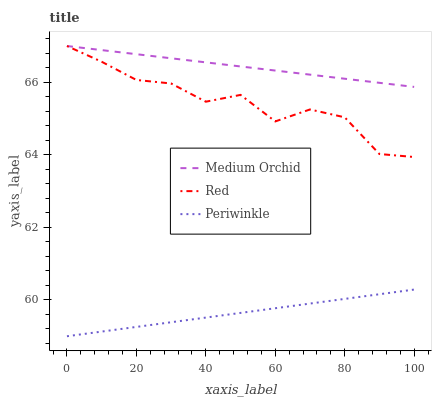Does Periwinkle have the minimum area under the curve?
Answer yes or no. Yes. Does Medium Orchid have the maximum area under the curve?
Answer yes or no. Yes. Does Red have the minimum area under the curve?
Answer yes or no. No. Does Red have the maximum area under the curve?
Answer yes or no. No. Is Medium Orchid the smoothest?
Answer yes or no. Yes. Is Red the roughest?
Answer yes or no. Yes. Is Periwinkle the smoothest?
Answer yes or no. No. Is Periwinkle the roughest?
Answer yes or no. No. Does Periwinkle have the lowest value?
Answer yes or no. Yes. Does Red have the lowest value?
Answer yes or no. No. Does Red have the highest value?
Answer yes or no. Yes. Does Periwinkle have the highest value?
Answer yes or no. No. Is Periwinkle less than Medium Orchid?
Answer yes or no. Yes. Is Medium Orchid greater than Periwinkle?
Answer yes or no. Yes. Does Red intersect Medium Orchid?
Answer yes or no. Yes. Is Red less than Medium Orchid?
Answer yes or no. No. Is Red greater than Medium Orchid?
Answer yes or no. No. Does Periwinkle intersect Medium Orchid?
Answer yes or no. No. 